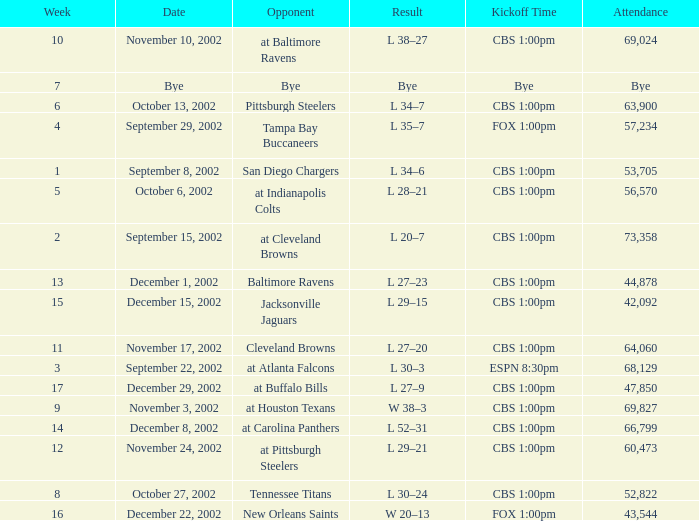Can you give me this table as a dict? {'header': ['Week', 'Date', 'Opponent', 'Result', 'Kickoff Time', 'Attendance'], 'rows': [['10', 'November 10, 2002', 'at Baltimore Ravens', 'L 38–27', 'CBS 1:00pm', '69,024'], ['7', 'Bye', 'Bye', 'Bye', 'Bye', 'Bye'], ['6', 'October 13, 2002', 'Pittsburgh Steelers', 'L 34–7', 'CBS 1:00pm', '63,900'], ['4', 'September 29, 2002', 'Tampa Bay Buccaneers', 'L 35–7', 'FOX 1:00pm', '57,234'], ['1', 'September 8, 2002', 'San Diego Chargers', 'L 34–6', 'CBS 1:00pm', '53,705'], ['5', 'October 6, 2002', 'at Indianapolis Colts', 'L 28–21', 'CBS 1:00pm', '56,570'], ['2', 'September 15, 2002', 'at Cleveland Browns', 'L 20–7', 'CBS 1:00pm', '73,358'], ['13', 'December 1, 2002', 'Baltimore Ravens', 'L 27–23', 'CBS 1:00pm', '44,878'], ['15', 'December 15, 2002', 'Jacksonville Jaguars', 'L 29–15', 'CBS 1:00pm', '42,092'], ['11', 'November 17, 2002', 'Cleveland Browns', 'L 27–20', 'CBS 1:00pm', '64,060'], ['3', 'September 22, 2002', 'at Atlanta Falcons', 'L 30–3', 'ESPN 8:30pm', '68,129'], ['17', 'December 29, 2002', 'at Buffalo Bills', 'L 27–9', 'CBS 1:00pm', '47,850'], ['9', 'November 3, 2002', 'at Houston Texans', 'W 38–3', 'CBS 1:00pm', '69,827'], ['14', 'December 8, 2002', 'at Carolina Panthers', 'L 52–31', 'CBS 1:00pm', '66,799'], ['12', 'November 24, 2002', 'at Pittsburgh Steelers', 'L 29–21', 'CBS 1:00pm', '60,473'], ['8', 'October 27, 2002', 'Tennessee Titans', 'L 30–24', 'CBS 1:00pm', '52,822'], ['16', 'December 22, 2002', 'New Orleans Saints', 'W 20–13', 'FOX 1:00pm', '43,544']]} What is the result of the game with 57,234 people in attendance? L 35–7. 